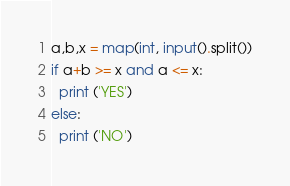Convert code to text. <code><loc_0><loc_0><loc_500><loc_500><_Python_>a,b,x = map(int, input().split())
if a+b >= x and a <= x:
  print ('YES')
else:
  print ('NO')</code> 